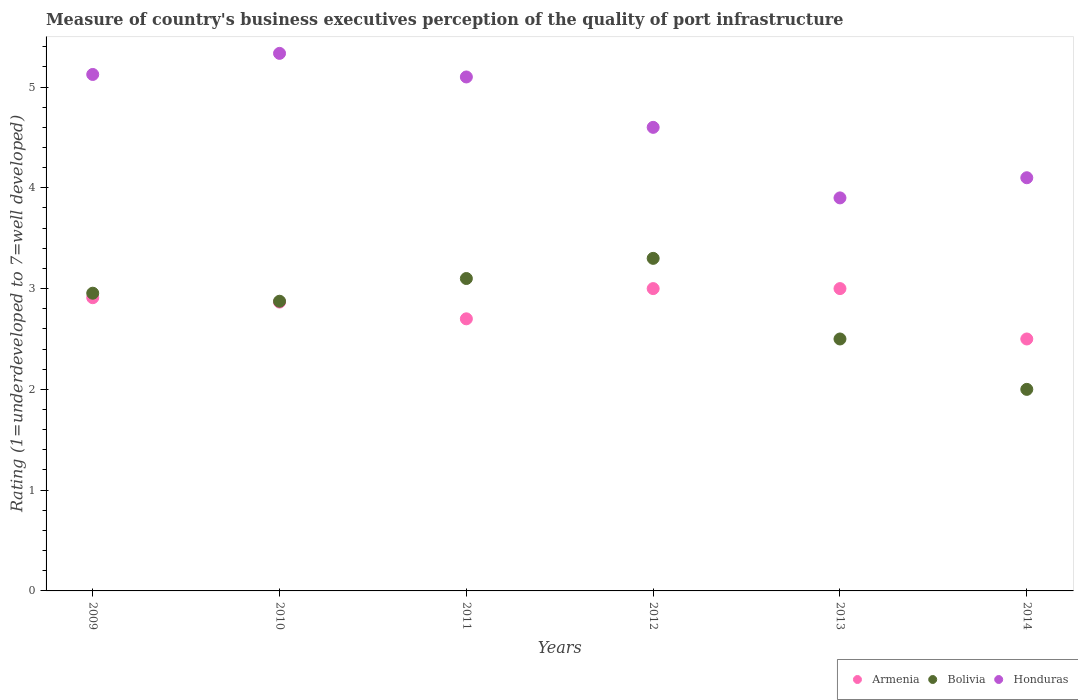How many different coloured dotlines are there?
Offer a terse response. 3. What is the ratings of the quality of port infrastructure in Bolivia in 2013?
Provide a succinct answer. 2.5. Across all years, what is the minimum ratings of the quality of port infrastructure in Bolivia?
Keep it short and to the point. 2. What is the total ratings of the quality of port infrastructure in Bolivia in the graph?
Make the answer very short. 16.73. What is the difference between the ratings of the quality of port infrastructure in Bolivia in 2009 and that in 2014?
Offer a terse response. 0.95. What is the difference between the ratings of the quality of port infrastructure in Honduras in 2013 and the ratings of the quality of port infrastructure in Armenia in 2009?
Provide a succinct answer. 0.99. What is the average ratings of the quality of port infrastructure in Bolivia per year?
Your answer should be compact. 2.79. In the year 2009, what is the difference between the ratings of the quality of port infrastructure in Honduras and ratings of the quality of port infrastructure in Bolivia?
Keep it short and to the point. 2.17. What is the ratio of the ratings of the quality of port infrastructure in Armenia in 2009 to that in 2014?
Your answer should be compact. 1.16. Is the difference between the ratings of the quality of port infrastructure in Honduras in 2009 and 2010 greater than the difference between the ratings of the quality of port infrastructure in Bolivia in 2009 and 2010?
Provide a short and direct response. No. What is the difference between the highest and the second highest ratings of the quality of port infrastructure in Armenia?
Make the answer very short. 0. What is the difference between the highest and the lowest ratings of the quality of port infrastructure in Bolivia?
Give a very brief answer. 1.3. In how many years, is the ratings of the quality of port infrastructure in Bolivia greater than the average ratings of the quality of port infrastructure in Bolivia taken over all years?
Give a very brief answer. 4. Is it the case that in every year, the sum of the ratings of the quality of port infrastructure in Armenia and ratings of the quality of port infrastructure in Bolivia  is greater than the ratings of the quality of port infrastructure in Honduras?
Your answer should be compact. Yes. Does the ratings of the quality of port infrastructure in Honduras monotonically increase over the years?
Provide a succinct answer. No. How many dotlines are there?
Make the answer very short. 3. How many years are there in the graph?
Ensure brevity in your answer.  6. Does the graph contain grids?
Give a very brief answer. No. Where does the legend appear in the graph?
Your response must be concise. Bottom right. How many legend labels are there?
Make the answer very short. 3. How are the legend labels stacked?
Offer a very short reply. Horizontal. What is the title of the graph?
Your answer should be very brief. Measure of country's business executives perception of the quality of port infrastructure. What is the label or title of the X-axis?
Provide a succinct answer. Years. What is the label or title of the Y-axis?
Give a very brief answer. Rating (1=underdeveloped to 7=well developed). What is the Rating (1=underdeveloped to 7=well developed) in Armenia in 2009?
Your answer should be compact. 2.91. What is the Rating (1=underdeveloped to 7=well developed) of Bolivia in 2009?
Your answer should be very brief. 2.95. What is the Rating (1=underdeveloped to 7=well developed) of Honduras in 2009?
Offer a very short reply. 5.12. What is the Rating (1=underdeveloped to 7=well developed) of Armenia in 2010?
Ensure brevity in your answer.  2.87. What is the Rating (1=underdeveloped to 7=well developed) in Bolivia in 2010?
Provide a short and direct response. 2.87. What is the Rating (1=underdeveloped to 7=well developed) in Honduras in 2010?
Give a very brief answer. 5.33. What is the Rating (1=underdeveloped to 7=well developed) of Armenia in 2012?
Your answer should be compact. 3. What is the Rating (1=underdeveloped to 7=well developed) of Bolivia in 2012?
Your answer should be very brief. 3.3. What is the Rating (1=underdeveloped to 7=well developed) in Honduras in 2012?
Offer a very short reply. 4.6. What is the Rating (1=underdeveloped to 7=well developed) of Bolivia in 2013?
Ensure brevity in your answer.  2.5. What is the Rating (1=underdeveloped to 7=well developed) of Honduras in 2013?
Provide a succinct answer. 3.9. What is the Rating (1=underdeveloped to 7=well developed) in Bolivia in 2014?
Offer a very short reply. 2. What is the Rating (1=underdeveloped to 7=well developed) in Honduras in 2014?
Your answer should be very brief. 4.1. Across all years, what is the maximum Rating (1=underdeveloped to 7=well developed) in Honduras?
Provide a short and direct response. 5.33. What is the total Rating (1=underdeveloped to 7=well developed) in Armenia in the graph?
Offer a terse response. 16.98. What is the total Rating (1=underdeveloped to 7=well developed) in Bolivia in the graph?
Your answer should be compact. 16.73. What is the total Rating (1=underdeveloped to 7=well developed) in Honduras in the graph?
Offer a terse response. 28.16. What is the difference between the Rating (1=underdeveloped to 7=well developed) in Armenia in 2009 and that in 2010?
Provide a succinct answer. 0.04. What is the difference between the Rating (1=underdeveloped to 7=well developed) in Bolivia in 2009 and that in 2010?
Give a very brief answer. 0.08. What is the difference between the Rating (1=underdeveloped to 7=well developed) of Honduras in 2009 and that in 2010?
Your response must be concise. -0.21. What is the difference between the Rating (1=underdeveloped to 7=well developed) in Armenia in 2009 and that in 2011?
Provide a short and direct response. 0.21. What is the difference between the Rating (1=underdeveloped to 7=well developed) in Bolivia in 2009 and that in 2011?
Ensure brevity in your answer.  -0.15. What is the difference between the Rating (1=underdeveloped to 7=well developed) of Honduras in 2009 and that in 2011?
Offer a terse response. 0.02. What is the difference between the Rating (1=underdeveloped to 7=well developed) in Armenia in 2009 and that in 2012?
Provide a short and direct response. -0.09. What is the difference between the Rating (1=underdeveloped to 7=well developed) in Bolivia in 2009 and that in 2012?
Make the answer very short. -0.35. What is the difference between the Rating (1=underdeveloped to 7=well developed) of Honduras in 2009 and that in 2012?
Keep it short and to the point. 0.52. What is the difference between the Rating (1=underdeveloped to 7=well developed) in Armenia in 2009 and that in 2013?
Give a very brief answer. -0.09. What is the difference between the Rating (1=underdeveloped to 7=well developed) in Bolivia in 2009 and that in 2013?
Keep it short and to the point. 0.45. What is the difference between the Rating (1=underdeveloped to 7=well developed) of Honduras in 2009 and that in 2013?
Your answer should be very brief. 1.22. What is the difference between the Rating (1=underdeveloped to 7=well developed) of Armenia in 2009 and that in 2014?
Your response must be concise. 0.41. What is the difference between the Rating (1=underdeveloped to 7=well developed) in Bolivia in 2009 and that in 2014?
Keep it short and to the point. 0.95. What is the difference between the Rating (1=underdeveloped to 7=well developed) of Honduras in 2009 and that in 2014?
Provide a short and direct response. 1.02. What is the difference between the Rating (1=underdeveloped to 7=well developed) of Armenia in 2010 and that in 2011?
Your answer should be very brief. 0.17. What is the difference between the Rating (1=underdeveloped to 7=well developed) in Bolivia in 2010 and that in 2011?
Your answer should be compact. -0.23. What is the difference between the Rating (1=underdeveloped to 7=well developed) of Honduras in 2010 and that in 2011?
Give a very brief answer. 0.23. What is the difference between the Rating (1=underdeveloped to 7=well developed) of Armenia in 2010 and that in 2012?
Provide a succinct answer. -0.13. What is the difference between the Rating (1=underdeveloped to 7=well developed) of Bolivia in 2010 and that in 2012?
Offer a terse response. -0.43. What is the difference between the Rating (1=underdeveloped to 7=well developed) in Honduras in 2010 and that in 2012?
Ensure brevity in your answer.  0.73. What is the difference between the Rating (1=underdeveloped to 7=well developed) in Armenia in 2010 and that in 2013?
Your answer should be very brief. -0.13. What is the difference between the Rating (1=underdeveloped to 7=well developed) of Bolivia in 2010 and that in 2013?
Make the answer very short. 0.37. What is the difference between the Rating (1=underdeveloped to 7=well developed) in Honduras in 2010 and that in 2013?
Offer a terse response. 1.43. What is the difference between the Rating (1=underdeveloped to 7=well developed) in Armenia in 2010 and that in 2014?
Offer a very short reply. 0.37. What is the difference between the Rating (1=underdeveloped to 7=well developed) of Bolivia in 2010 and that in 2014?
Offer a terse response. 0.87. What is the difference between the Rating (1=underdeveloped to 7=well developed) of Honduras in 2010 and that in 2014?
Ensure brevity in your answer.  1.23. What is the difference between the Rating (1=underdeveloped to 7=well developed) of Bolivia in 2011 and that in 2012?
Your answer should be very brief. -0.2. What is the difference between the Rating (1=underdeveloped to 7=well developed) of Bolivia in 2011 and that in 2013?
Your response must be concise. 0.6. What is the difference between the Rating (1=underdeveloped to 7=well developed) in Armenia in 2011 and that in 2014?
Ensure brevity in your answer.  0.2. What is the difference between the Rating (1=underdeveloped to 7=well developed) of Honduras in 2011 and that in 2014?
Give a very brief answer. 1. What is the difference between the Rating (1=underdeveloped to 7=well developed) of Armenia in 2012 and that in 2013?
Provide a succinct answer. 0. What is the difference between the Rating (1=underdeveloped to 7=well developed) in Armenia in 2012 and that in 2014?
Keep it short and to the point. 0.5. What is the difference between the Rating (1=underdeveloped to 7=well developed) in Honduras in 2012 and that in 2014?
Your answer should be very brief. 0.5. What is the difference between the Rating (1=underdeveloped to 7=well developed) of Bolivia in 2013 and that in 2014?
Ensure brevity in your answer.  0.5. What is the difference between the Rating (1=underdeveloped to 7=well developed) in Honduras in 2013 and that in 2014?
Keep it short and to the point. -0.2. What is the difference between the Rating (1=underdeveloped to 7=well developed) of Armenia in 2009 and the Rating (1=underdeveloped to 7=well developed) of Bolivia in 2010?
Ensure brevity in your answer.  0.04. What is the difference between the Rating (1=underdeveloped to 7=well developed) in Armenia in 2009 and the Rating (1=underdeveloped to 7=well developed) in Honduras in 2010?
Give a very brief answer. -2.42. What is the difference between the Rating (1=underdeveloped to 7=well developed) in Bolivia in 2009 and the Rating (1=underdeveloped to 7=well developed) in Honduras in 2010?
Give a very brief answer. -2.38. What is the difference between the Rating (1=underdeveloped to 7=well developed) of Armenia in 2009 and the Rating (1=underdeveloped to 7=well developed) of Bolivia in 2011?
Provide a short and direct response. -0.19. What is the difference between the Rating (1=underdeveloped to 7=well developed) in Armenia in 2009 and the Rating (1=underdeveloped to 7=well developed) in Honduras in 2011?
Offer a terse response. -2.19. What is the difference between the Rating (1=underdeveloped to 7=well developed) of Bolivia in 2009 and the Rating (1=underdeveloped to 7=well developed) of Honduras in 2011?
Provide a succinct answer. -2.15. What is the difference between the Rating (1=underdeveloped to 7=well developed) of Armenia in 2009 and the Rating (1=underdeveloped to 7=well developed) of Bolivia in 2012?
Keep it short and to the point. -0.39. What is the difference between the Rating (1=underdeveloped to 7=well developed) in Armenia in 2009 and the Rating (1=underdeveloped to 7=well developed) in Honduras in 2012?
Offer a terse response. -1.69. What is the difference between the Rating (1=underdeveloped to 7=well developed) of Bolivia in 2009 and the Rating (1=underdeveloped to 7=well developed) of Honduras in 2012?
Offer a very short reply. -1.65. What is the difference between the Rating (1=underdeveloped to 7=well developed) of Armenia in 2009 and the Rating (1=underdeveloped to 7=well developed) of Bolivia in 2013?
Offer a very short reply. 0.41. What is the difference between the Rating (1=underdeveloped to 7=well developed) of Armenia in 2009 and the Rating (1=underdeveloped to 7=well developed) of Honduras in 2013?
Provide a succinct answer. -0.99. What is the difference between the Rating (1=underdeveloped to 7=well developed) of Bolivia in 2009 and the Rating (1=underdeveloped to 7=well developed) of Honduras in 2013?
Give a very brief answer. -0.95. What is the difference between the Rating (1=underdeveloped to 7=well developed) of Armenia in 2009 and the Rating (1=underdeveloped to 7=well developed) of Bolivia in 2014?
Keep it short and to the point. 0.91. What is the difference between the Rating (1=underdeveloped to 7=well developed) of Armenia in 2009 and the Rating (1=underdeveloped to 7=well developed) of Honduras in 2014?
Your answer should be compact. -1.19. What is the difference between the Rating (1=underdeveloped to 7=well developed) of Bolivia in 2009 and the Rating (1=underdeveloped to 7=well developed) of Honduras in 2014?
Your response must be concise. -1.15. What is the difference between the Rating (1=underdeveloped to 7=well developed) of Armenia in 2010 and the Rating (1=underdeveloped to 7=well developed) of Bolivia in 2011?
Ensure brevity in your answer.  -0.23. What is the difference between the Rating (1=underdeveloped to 7=well developed) of Armenia in 2010 and the Rating (1=underdeveloped to 7=well developed) of Honduras in 2011?
Make the answer very short. -2.23. What is the difference between the Rating (1=underdeveloped to 7=well developed) in Bolivia in 2010 and the Rating (1=underdeveloped to 7=well developed) in Honduras in 2011?
Provide a short and direct response. -2.23. What is the difference between the Rating (1=underdeveloped to 7=well developed) of Armenia in 2010 and the Rating (1=underdeveloped to 7=well developed) of Bolivia in 2012?
Your response must be concise. -0.43. What is the difference between the Rating (1=underdeveloped to 7=well developed) of Armenia in 2010 and the Rating (1=underdeveloped to 7=well developed) of Honduras in 2012?
Offer a very short reply. -1.73. What is the difference between the Rating (1=underdeveloped to 7=well developed) in Bolivia in 2010 and the Rating (1=underdeveloped to 7=well developed) in Honduras in 2012?
Offer a terse response. -1.73. What is the difference between the Rating (1=underdeveloped to 7=well developed) in Armenia in 2010 and the Rating (1=underdeveloped to 7=well developed) in Bolivia in 2013?
Your answer should be very brief. 0.37. What is the difference between the Rating (1=underdeveloped to 7=well developed) in Armenia in 2010 and the Rating (1=underdeveloped to 7=well developed) in Honduras in 2013?
Provide a short and direct response. -1.03. What is the difference between the Rating (1=underdeveloped to 7=well developed) of Bolivia in 2010 and the Rating (1=underdeveloped to 7=well developed) of Honduras in 2013?
Offer a very short reply. -1.03. What is the difference between the Rating (1=underdeveloped to 7=well developed) of Armenia in 2010 and the Rating (1=underdeveloped to 7=well developed) of Bolivia in 2014?
Provide a short and direct response. 0.87. What is the difference between the Rating (1=underdeveloped to 7=well developed) in Armenia in 2010 and the Rating (1=underdeveloped to 7=well developed) in Honduras in 2014?
Provide a short and direct response. -1.23. What is the difference between the Rating (1=underdeveloped to 7=well developed) of Bolivia in 2010 and the Rating (1=underdeveloped to 7=well developed) of Honduras in 2014?
Make the answer very short. -1.23. What is the difference between the Rating (1=underdeveloped to 7=well developed) in Bolivia in 2011 and the Rating (1=underdeveloped to 7=well developed) in Honduras in 2012?
Make the answer very short. -1.5. What is the difference between the Rating (1=underdeveloped to 7=well developed) in Bolivia in 2011 and the Rating (1=underdeveloped to 7=well developed) in Honduras in 2013?
Your answer should be very brief. -0.8. What is the difference between the Rating (1=underdeveloped to 7=well developed) of Armenia in 2011 and the Rating (1=underdeveloped to 7=well developed) of Bolivia in 2014?
Make the answer very short. 0.7. What is the difference between the Rating (1=underdeveloped to 7=well developed) of Armenia in 2012 and the Rating (1=underdeveloped to 7=well developed) of Bolivia in 2013?
Offer a terse response. 0.5. What is the difference between the Rating (1=underdeveloped to 7=well developed) in Armenia in 2012 and the Rating (1=underdeveloped to 7=well developed) in Bolivia in 2014?
Offer a terse response. 1. What is the difference between the Rating (1=underdeveloped to 7=well developed) in Armenia in 2012 and the Rating (1=underdeveloped to 7=well developed) in Honduras in 2014?
Provide a short and direct response. -1.1. What is the difference between the Rating (1=underdeveloped to 7=well developed) of Bolivia in 2012 and the Rating (1=underdeveloped to 7=well developed) of Honduras in 2014?
Provide a succinct answer. -0.8. What is the difference between the Rating (1=underdeveloped to 7=well developed) of Armenia in 2013 and the Rating (1=underdeveloped to 7=well developed) of Bolivia in 2014?
Your answer should be compact. 1. What is the difference between the Rating (1=underdeveloped to 7=well developed) of Bolivia in 2013 and the Rating (1=underdeveloped to 7=well developed) of Honduras in 2014?
Make the answer very short. -1.6. What is the average Rating (1=underdeveloped to 7=well developed) in Armenia per year?
Your answer should be compact. 2.83. What is the average Rating (1=underdeveloped to 7=well developed) in Bolivia per year?
Give a very brief answer. 2.79. What is the average Rating (1=underdeveloped to 7=well developed) in Honduras per year?
Provide a short and direct response. 4.69. In the year 2009, what is the difference between the Rating (1=underdeveloped to 7=well developed) in Armenia and Rating (1=underdeveloped to 7=well developed) in Bolivia?
Offer a terse response. -0.04. In the year 2009, what is the difference between the Rating (1=underdeveloped to 7=well developed) in Armenia and Rating (1=underdeveloped to 7=well developed) in Honduras?
Keep it short and to the point. -2.22. In the year 2009, what is the difference between the Rating (1=underdeveloped to 7=well developed) of Bolivia and Rating (1=underdeveloped to 7=well developed) of Honduras?
Your answer should be very brief. -2.17. In the year 2010, what is the difference between the Rating (1=underdeveloped to 7=well developed) in Armenia and Rating (1=underdeveloped to 7=well developed) in Bolivia?
Make the answer very short. -0.01. In the year 2010, what is the difference between the Rating (1=underdeveloped to 7=well developed) in Armenia and Rating (1=underdeveloped to 7=well developed) in Honduras?
Give a very brief answer. -2.47. In the year 2010, what is the difference between the Rating (1=underdeveloped to 7=well developed) of Bolivia and Rating (1=underdeveloped to 7=well developed) of Honduras?
Your response must be concise. -2.46. In the year 2011, what is the difference between the Rating (1=underdeveloped to 7=well developed) of Armenia and Rating (1=underdeveloped to 7=well developed) of Bolivia?
Your response must be concise. -0.4. In the year 2011, what is the difference between the Rating (1=underdeveloped to 7=well developed) in Armenia and Rating (1=underdeveloped to 7=well developed) in Honduras?
Make the answer very short. -2.4. In the year 2012, what is the difference between the Rating (1=underdeveloped to 7=well developed) of Armenia and Rating (1=underdeveloped to 7=well developed) of Honduras?
Your answer should be very brief. -1.6. In the year 2012, what is the difference between the Rating (1=underdeveloped to 7=well developed) in Bolivia and Rating (1=underdeveloped to 7=well developed) in Honduras?
Make the answer very short. -1.3. In the year 2013, what is the difference between the Rating (1=underdeveloped to 7=well developed) in Armenia and Rating (1=underdeveloped to 7=well developed) in Bolivia?
Provide a short and direct response. 0.5. In the year 2013, what is the difference between the Rating (1=underdeveloped to 7=well developed) of Armenia and Rating (1=underdeveloped to 7=well developed) of Honduras?
Offer a terse response. -0.9. In the year 2013, what is the difference between the Rating (1=underdeveloped to 7=well developed) in Bolivia and Rating (1=underdeveloped to 7=well developed) in Honduras?
Your response must be concise. -1.4. What is the ratio of the Rating (1=underdeveloped to 7=well developed) in Armenia in 2009 to that in 2010?
Make the answer very short. 1.02. What is the ratio of the Rating (1=underdeveloped to 7=well developed) of Bolivia in 2009 to that in 2010?
Your answer should be compact. 1.03. What is the ratio of the Rating (1=underdeveloped to 7=well developed) of Honduras in 2009 to that in 2010?
Provide a short and direct response. 0.96. What is the ratio of the Rating (1=underdeveloped to 7=well developed) in Armenia in 2009 to that in 2011?
Offer a very short reply. 1.08. What is the ratio of the Rating (1=underdeveloped to 7=well developed) of Bolivia in 2009 to that in 2011?
Your response must be concise. 0.95. What is the ratio of the Rating (1=underdeveloped to 7=well developed) of Honduras in 2009 to that in 2011?
Your answer should be very brief. 1. What is the ratio of the Rating (1=underdeveloped to 7=well developed) of Armenia in 2009 to that in 2012?
Offer a very short reply. 0.97. What is the ratio of the Rating (1=underdeveloped to 7=well developed) of Bolivia in 2009 to that in 2012?
Provide a short and direct response. 0.9. What is the ratio of the Rating (1=underdeveloped to 7=well developed) of Honduras in 2009 to that in 2012?
Offer a very short reply. 1.11. What is the ratio of the Rating (1=underdeveloped to 7=well developed) in Armenia in 2009 to that in 2013?
Offer a terse response. 0.97. What is the ratio of the Rating (1=underdeveloped to 7=well developed) in Bolivia in 2009 to that in 2013?
Your answer should be compact. 1.18. What is the ratio of the Rating (1=underdeveloped to 7=well developed) in Honduras in 2009 to that in 2013?
Provide a succinct answer. 1.31. What is the ratio of the Rating (1=underdeveloped to 7=well developed) in Armenia in 2009 to that in 2014?
Give a very brief answer. 1.16. What is the ratio of the Rating (1=underdeveloped to 7=well developed) of Bolivia in 2009 to that in 2014?
Ensure brevity in your answer.  1.48. What is the ratio of the Rating (1=underdeveloped to 7=well developed) in Honduras in 2009 to that in 2014?
Make the answer very short. 1.25. What is the ratio of the Rating (1=underdeveloped to 7=well developed) in Armenia in 2010 to that in 2011?
Provide a succinct answer. 1.06. What is the ratio of the Rating (1=underdeveloped to 7=well developed) of Bolivia in 2010 to that in 2011?
Your answer should be very brief. 0.93. What is the ratio of the Rating (1=underdeveloped to 7=well developed) in Honduras in 2010 to that in 2011?
Provide a short and direct response. 1.05. What is the ratio of the Rating (1=underdeveloped to 7=well developed) in Armenia in 2010 to that in 2012?
Keep it short and to the point. 0.96. What is the ratio of the Rating (1=underdeveloped to 7=well developed) in Bolivia in 2010 to that in 2012?
Offer a terse response. 0.87. What is the ratio of the Rating (1=underdeveloped to 7=well developed) of Honduras in 2010 to that in 2012?
Ensure brevity in your answer.  1.16. What is the ratio of the Rating (1=underdeveloped to 7=well developed) in Armenia in 2010 to that in 2013?
Offer a very short reply. 0.96. What is the ratio of the Rating (1=underdeveloped to 7=well developed) of Bolivia in 2010 to that in 2013?
Ensure brevity in your answer.  1.15. What is the ratio of the Rating (1=underdeveloped to 7=well developed) of Honduras in 2010 to that in 2013?
Give a very brief answer. 1.37. What is the ratio of the Rating (1=underdeveloped to 7=well developed) in Armenia in 2010 to that in 2014?
Your answer should be compact. 1.15. What is the ratio of the Rating (1=underdeveloped to 7=well developed) in Bolivia in 2010 to that in 2014?
Keep it short and to the point. 1.44. What is the ratio of the Rating (1=underdeveloped to 7=well developed) of Honduras in 2010 to that in 2014?
Provide a short and direct response. 1.3. What is the ratio of the Rating (1=underdeveloped to 7=well developed) in Bolivia in 2011 to that in 2012?
Ensure brevity in your answer.  0.94. What is the ratio of the Rating (1=underdeveloped to 7=well developed) in Honduras in 2011 to that in 2012?
Offer a very short reply. 1.11. What is the ratio of the Rating (1=underdeveloped to 7=well developed) of Bolivia in 2011 to that in 2013?
Offer a terse response. 1.24. What is the ratio of the Rating (1=underdeveloped to 7=well developed) of Honduras in 2011 to that in 2013?
Your answer should be very brief. 1.31. What is the ratio of the Rating (1=underdeveloped to 7=well developed) of Armenia in 2011 to that in 2014?
Your answer should be very brief. 1.08. What is the ratio of the Rating (1=underdeveloped to 7=well developed) of Bolivia in 2011 to that in 2014?
Your answer should be very brief. 1.55. What is the ratio of the Rating (1=underdeveloped to 7=well developed) of Honduras in 2011 to that in 2014?
Your answer should be very brief. 1.24. What is the ratio of the Rating (1=underdeveloped to 7=well developed) of Armenia in 2012 to that in 2013?
Your answer should be compact. 1. What is the ratio of the Rating (1=underdeveloped to 7=well developed) in Bolivia in 2012 to that in 2013?
Offer a terse response. 1.32. What is the ratio of the Rating (1=underdeveloped to 7=well developed) of Honduras in 2012 to that in 2013?
Your answer should be very brief. 1.18. What is the ratio of the Rating (1=underdeveloped to 7=well developed) of Armenia in 2012 to that in 2014?
Offer a terse response. 1.2. What is the ratio of the Rating (1=underdeveloped to 7=well developed) of Bolivia in 2012 to that in 2014?
Provide a short and direct response. 1.65. What is the ratio of the Rating (1=underdeveloped to 7=well developed) in Honduras in 2012 to that in 2014?
Offer a terse response. 1.12. What is the ratio of the Rating (1=underdeveloped to 7=well developed) of Armenia in 2013 to that in 2014?
Keep it short and to the point. 1.2. What is the ratio of the Rating (1=underdeveloped to 7=well developed) in Bolivia in 2013 to that in 2014?
Provide a short and direct response. 1.25. What is the ratio of the Rating (1=underdeveloped to 7=well developed) of Honduras in 2013 to that in 2014?
Offer a very short reply. 0.95. What is the difference between the highest and the second highest Rating (1=underdeveloped to 7=well developed) of Armenia?
Give a very brief answer. 0. What is the difference between the highest and the second highest Rating (1=underdeveloped to 7=well developed) in Bolivia?
Provide a short and direct response. 0.2. What is the difference between the highest and the second highest Rating (1=underdeveloped to 7=well developed) in Honduras?
Your answer should be very brief. 0.21. What is the difference between the highest and the lowest Rating (1=underdeveloped to 7=well developed) of Bolivia?
Keep it short and to the point. 1.3. What is the difference between the highest and the lowest Rating (1=underdeveloped to 7=well developed) of Honduras?
Provide a short and direct response. 1.43. 